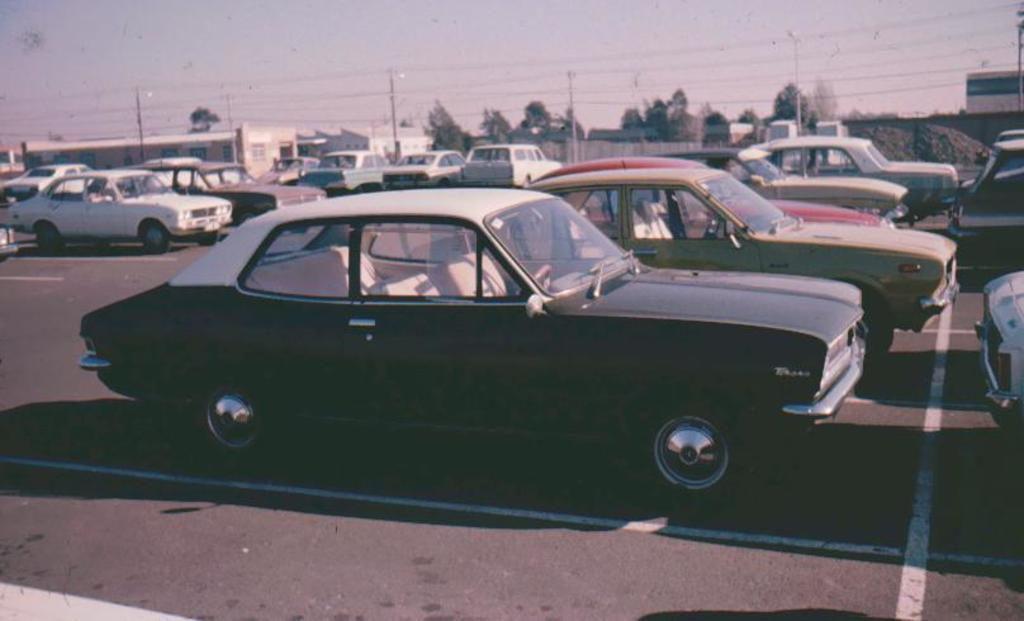What is the main subject of the image? There is a car in the image. What else can be seen in the image besides the car? Electrical poles, wires, trees, and the sky are visible in the image. Can you describe the electrical poles in the image? There are electrical poles in the image, which are typically used to support electrical wires. What is visible in the background of the image? The sky is visible in the background of the image. What type of news can be heard coming from the car in the image? There is no indication in the image that the car is broadcasting news, so it's not possible to determine what, if any, news might be heard. 